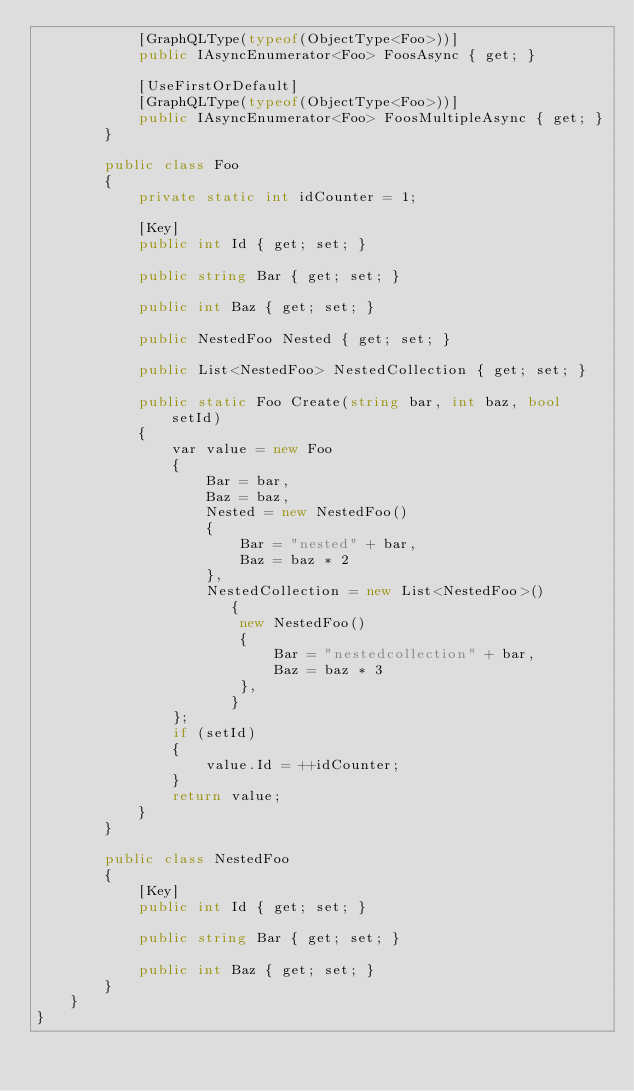Convert code to text. <code><loc_0><loc_0><loc_500><loc_500><_C#_>            [GraphQLType(typeof(ObjectType<Foo>))]
            public IAsyncEnumerator<Foo> FoosAsync { get; }

            [UseFirstOrDefault]
            [GraphQLType(typeof(ObjectType<Foo>))]
            public IAsyncEnumerator<Foo> FoosMultipleAsync { get; }
        }

        public class Foo
        {
            private static int idCounter = 1;

            [Key]
            public int Id { get; set; }

            public string Bar { get; set; }

            public int Baz { get; set; }

            public NestedFoo Nested { get; set; }

            public List<NestedFoo> NestedCollection { get; set; }

            public static Foo Create(string bar, int baz, bool setId)
            {
                var value = new Foo
                {
                    Bar = bar,
                    Baz = baz,
                    Nested = new NestedFoo()
                    {
                        Bar = "nested" + bar,
                        Baz = baz * 2
                    },
                    NestedCollection = new List<NestedFoo>()
                       {
                        new NestedFoo()
                        {
                            Bar = "nestedcollection" + bar,
                            Baz = baz * 3
                        },
                       }
                };
                if (setId)
                {
                    value.Id = ++idCounter;
                }
                return value;
            }
        }

        public class NestedFoo
        {
            [Key]
            public int Id { get; set; }

            public string Bar { get; set; }

            public int Baz { get; set; }
        }
    }
}
</code> 